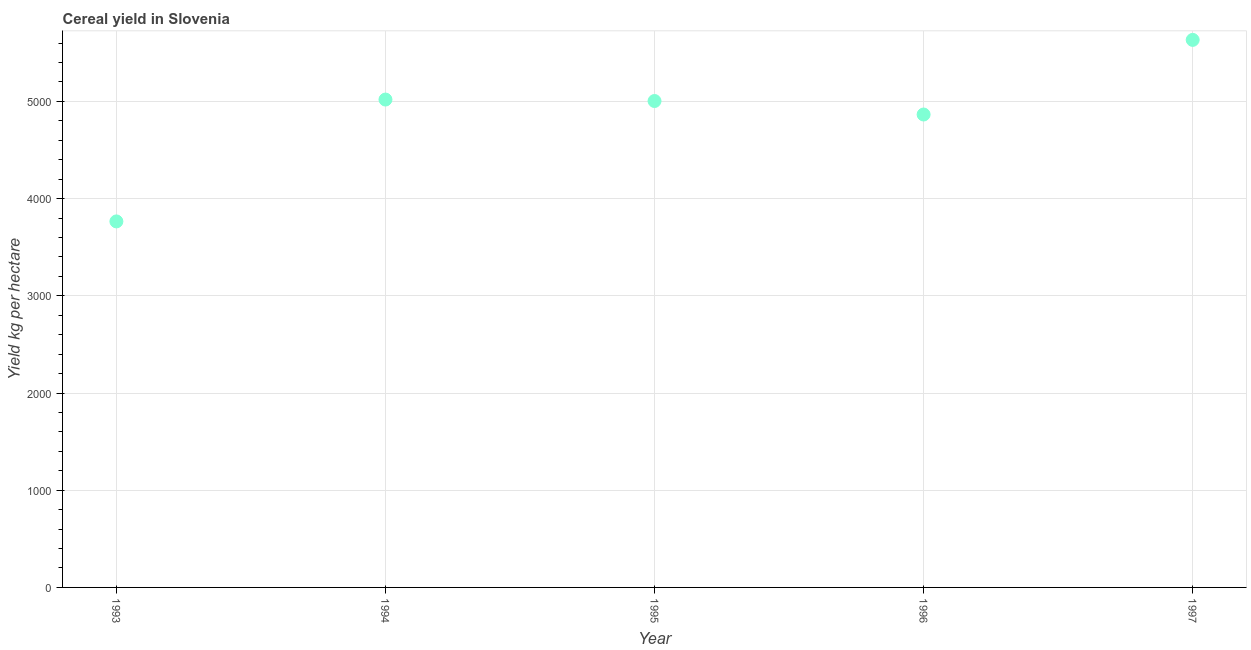What is the cereal yield in 1994?
Give a very brief answer. 5018.67. Across all years, what is the maximum cereal yield?
Offer a very short reply. 5632.32. Across all years, what is the minimum cereal yield?
Ensure brevity in your answer.  3765.14. What is the sum of the cereal yield?
Provide a short and direct response. 2.43e+04. What is the difference between the cereal yield in 1994 and 1996?
Provide a succinct answer. 153.82. What is the average cereal yield per year?
Offer a very short reply. 4856.93. What is the median cereal yield?
Ensure brevity in your answer.  5003.65. Do a majority of the years between 1995 and 1993 (inclusive) have cereal yield greater than 5000 kg per hectare?
Your response must be concise. No. What is the ratio of the cereal yield in 1995 to that in 1997?
Keep it short and to the point. 0.89. Is the cereal yield in 1994 less than that in 1996?
Your answer should be compact. No. Is the difference between the cereal yield in 1996 and 1997 greater than the difference between any two years?
Ensure brevity in your answer.  No. What is the difference between the highest and the second highest cereal yield?
Keep it short and to the point. 613.65. What is the difference between the highest and the lowest cereal yield?
Offer a very short reply. 1867.18. In how many years, is the cereal yield greater than the average cereal yield taken over all years?
Ensure brevity in your answer.  4. How many dotlines are there?
Give a very brief answer. 1. How many years are there in the graph?
Your answer should be compact. 5. What is the title of the graph?
Your answer should be very brief. Cereal yield in Slovenia. What is the label or title of the X-axis?
Provide a short and direct response. Year. What is the label or title of the Y-axis?
Your answer should be compact. Yield kg per hectare. What is the Yield kg per hectare in 1993?
Give a very brief answer. 3765.14. What is the Yield kg per hectare in 1994?
Provide a short and direct response. 5018.67. What is the Yield kg per hectare in 1995?
Offer a terse response. 5003.65. What is the Yield kg per hectare in 1996?
Give a very brief answer. 4864.85. What is the Yield kg per hectare in 1997?
Your answer should be compact. 5632.32. What is the difference between the Yield kg per hectare in 1993 and 1994?
Provide a succinct answer. -1253.53. What is the difference between the Yield kg per hectare in 1993 and 1995?
Provide a succinct answer. -1238.52. What is the difference between the Yield kg per hectare in 1993 and 1996?
Make the answer very short. -1099.71. What is the difference between the Yield kg per hectare in 1993 and 1997?
Give a very brief answer. -1867.18. What is the difference between the Yield kg per hectare in 1994 and 1995?
Provide a succinct answer. 15.02. What is the difference between the Yield kg per hectare in 1994 and 1996?
Your answer should be very brief. 153.82. What is the difference between the Yield kg per hectare in 1994 and 1997?
Your response must be concise. -613.65. What is the difference between the Yield kg per hectare in 1995 and 1996?
Your response must be concise. 138.8. What is the difference between the Yield kg per hectare in 1995 and 1997?
Make the answer very short. -628.67. What is the difference between the Yield kg per hectare in 1996 and 1997?
Your response must be concise. -767.47. What is the ratio of the Yield kg per hectare in 1993 to that in 1994?
Give a very brief answer. 0.75. What is the ratio of the Yield kg per hectare in 1993 to that in 1995?
Keep it short and to the point. 0.75. What is the ratio of the Yield kg per hectare in 1993 to that in 1996?
Offer a very short reply. 0.77. What is the ratio of the Yield kg per hectare in 1993 to that in 1997?
Provide a short and direct response. 0.67. What is the ratio of the Yield kg per hectare in 1994 to that in 1995?
Keep it short and to the point. 1. What is the ratio of the Yield kg per hectare in 1994 to that in 1996?
Make the answer very short. 1.03. What is the ratio of the Yield kg per hectare in 1994 to that in 1997?
Offer a very short reply. 0.89. What is the ratio of the Yield kg per hectare in 1995 to that in 1996?
Offer a terse response. 1.03. What is the ratio of the Yield kg per hectare in 1995 to that in 1997?
Offer a very short reply. 0.89. What is the ratio of the Yield kg per hectare in 1996 to that in 1997?
Your response must be concise. 0.86. 